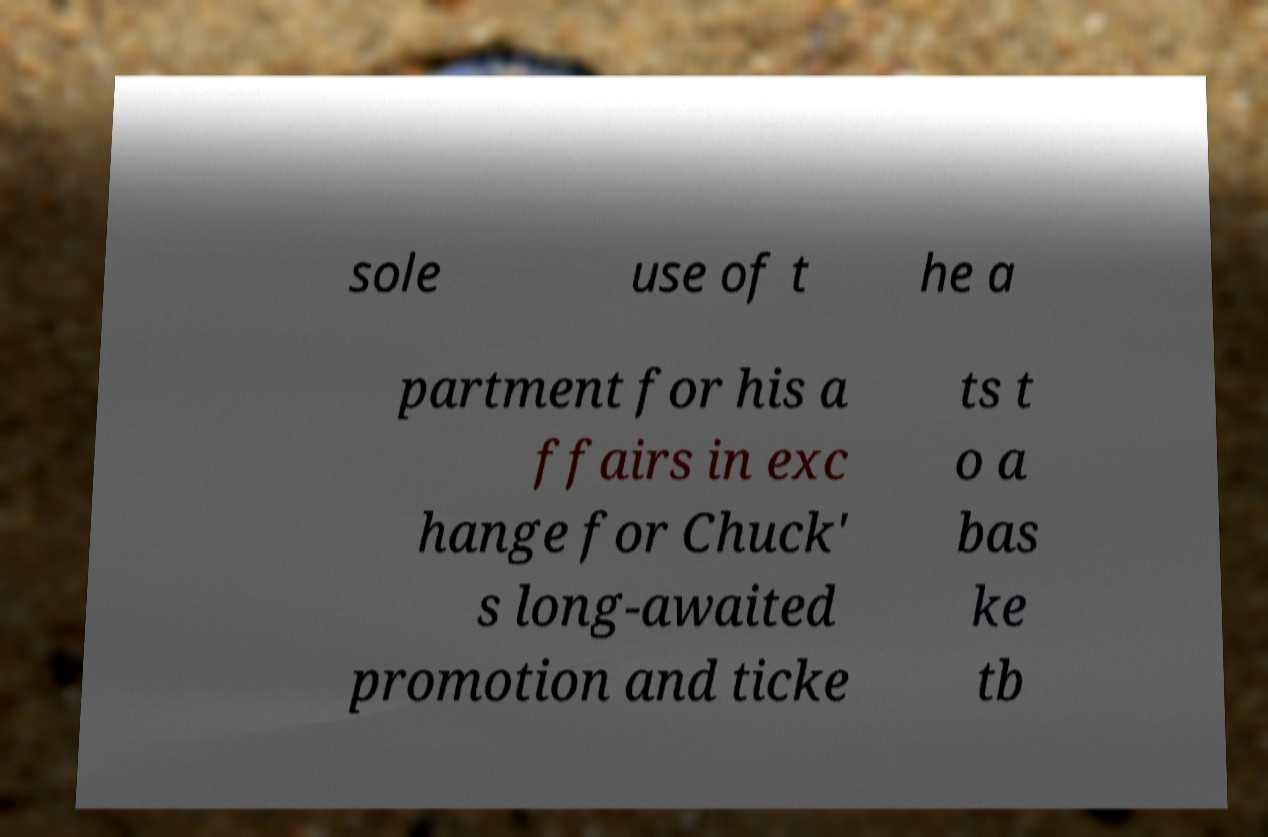Please identify and transcribe the text found in this image. sole use of t he a partment for his a ffairs in exc hange for Chuck' s long-awaited promotion and ticke ts t o a bas ke tb 